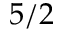Convert formula to latex. <formula><loc_0><loc_0><loc_500><loc_500>5 / 2</formula> 